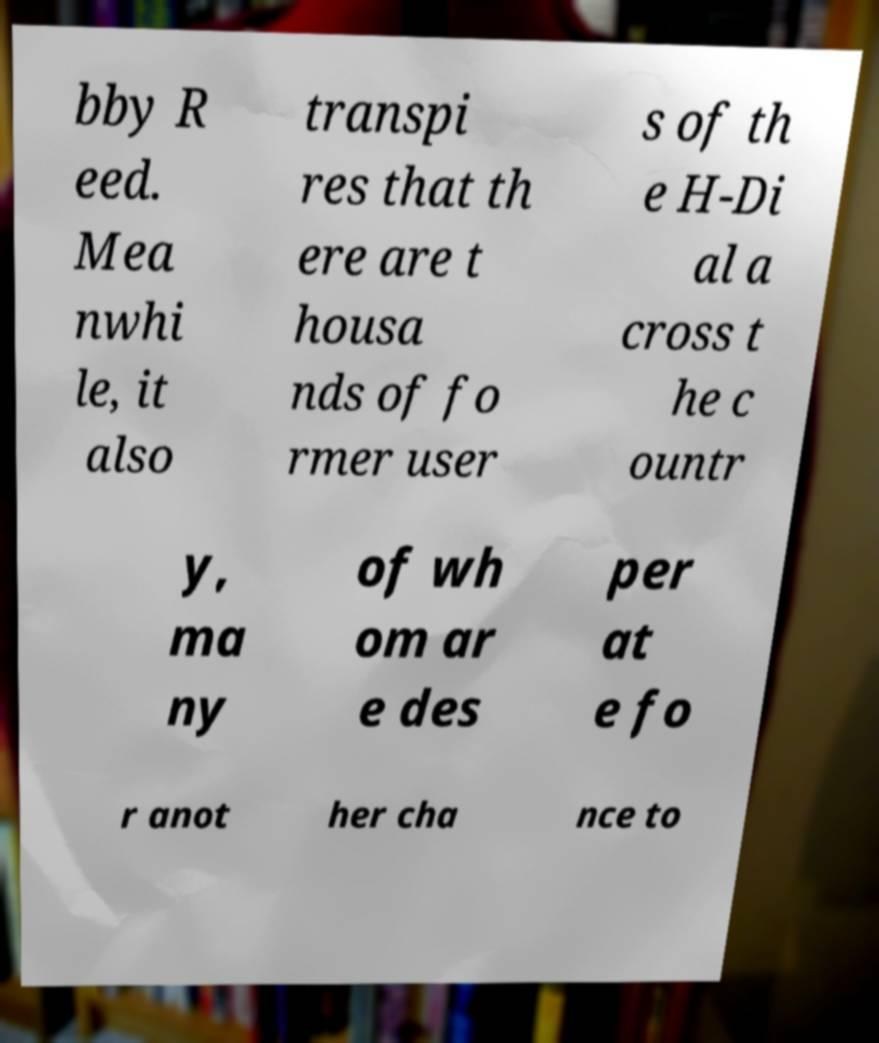There's text embedded in this image that I need extracted. Can you transcribe it verbatim? bby R eed. Mea nwhi le, it also transpi res that th ere are t housa nds of fo rmer user s of th e H-Di al a cross t he c ountr y, ma ny of wh om ar e des per at e fo r anot her cha nce to 